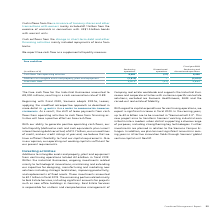According to Siemens Ag's financial document, What was the Free cash flow for the Industrial Businesses? Based on the financial document, the answer is €8,000 millions. Also, What is the source for capital funding requirement? Based on the financial document, the answer is With our ability to generate positive operating cash flows, our total liquidity (defined as cash and cash equivalents plus current interest-bearing debt securities) of €13.7 billion, our unused lines of credit, and our credit ratings at year-end, we believe that we have sufficient flexibility to fund our capital requirements.. Also, What is the cash conversion rate? According to the financial document, 0.89. The relevant text states: "illions, resulting in a cash conversation rate of 0.89...." Also, can you calculate: What was the average cash flow from operating activities from continuing and discontinued operations? To answer this question, I need to perform calculations using the financial data. The calculation is: (8,482 - 27) / 2, which equals 4227.5 (in millions). This is based on the information: "Cash flows from operating activities 8,482 (27) 8,456 Cash flows from operating activities 8,482 (27) 8,456..." The key data points involved are: 8,482. Also, can you calculate: What is the increase / (decrease) of continuing operations compared to the discontinued operations for Additions to intangible assets and property, plant and equipment? Based on the calculation: (2,610 - 0), the result is 2610 (in millions). This is based on the information: "angible assets and property, plant and equipment (2,610) − (2,610) angible assets and property, plant and equipment (2,610) − (2,610)..." The key data points involved are: 2,610. Also, can you calculate: What percentage increase / (decrease) is Free cash flow in continuing operations compared to discontinued operations? To answer this question, I need to perform calculations using the financial data. The calculation is: - (5,872 / -27 - 1), which equals 218.48 (percentage). This is based on the information: "Free cash flow 5,872 (27) 5,845 Free cash flow 5,872 (27) 5,845..." The key data points involved are: 27, 5,872. 